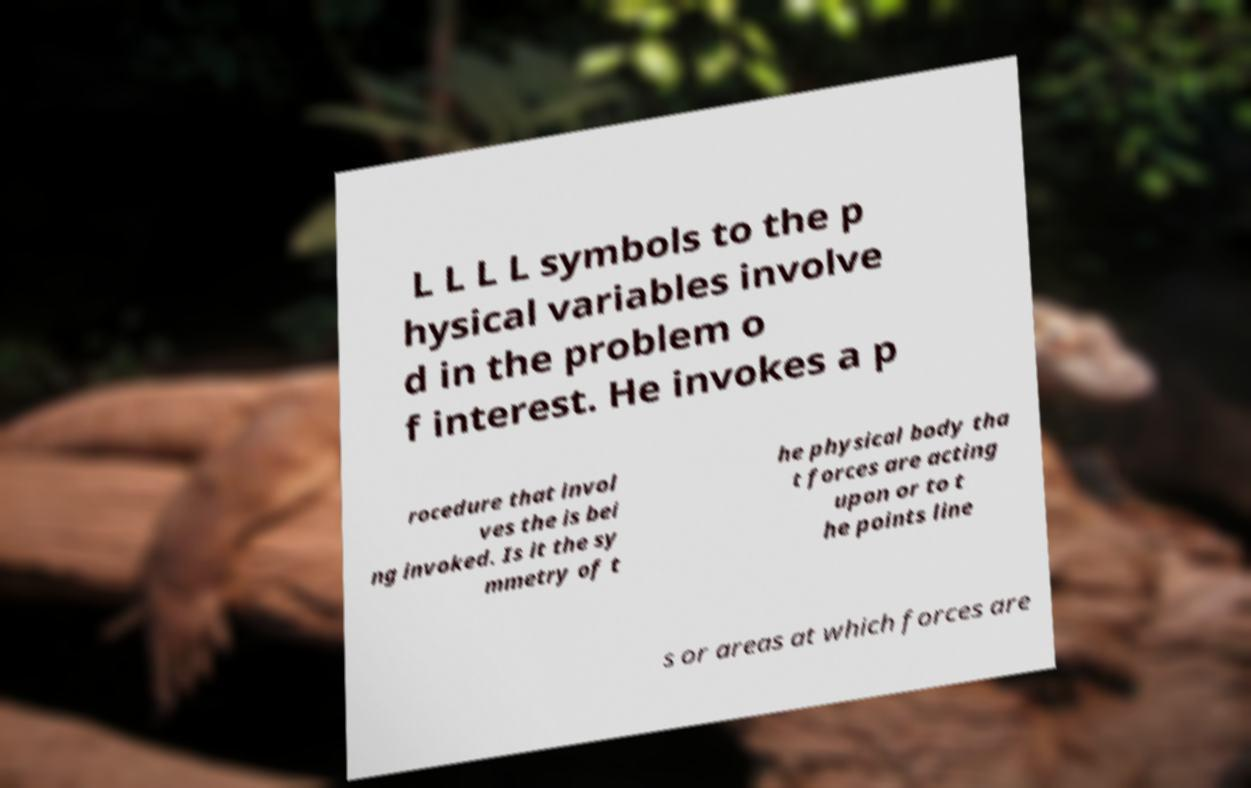Could you extract and type out the text from this image? L L L L symbols to the p hysical variables involve d in the problem o f interest. He invokes a p rocedure that invol ves the is bei ng invoked. Is it the sy mmetry of t he physical body tha t forces are acting upon or to t he points line s or areas at which forces are 